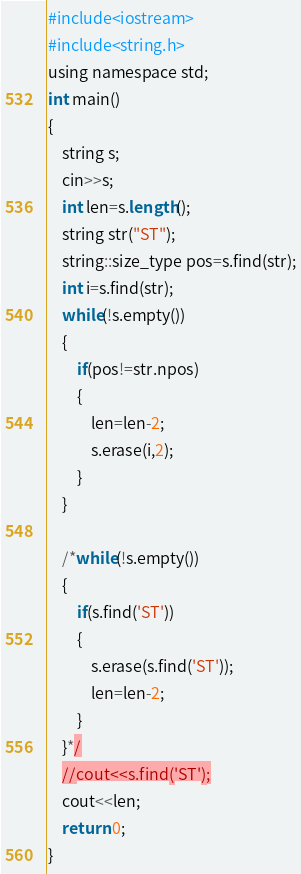<code> <loc_0><loc_0><loc_500><loc_500><_Awk_>#include<iostream>
#include<string.h>
using namespace std;
int main()
{
	string s;
	cin>>s;
	int len=s.length();
	string str("ST");
	string::size_type pos=s.find(str);
    int i=s.find(str);
    while(!s.empty())
    {
    	if(pos!=str.npos)
	    {
		    len=len-2;
		    s.erase(i,2);
	    }
	}
	
	/*while(!s.empty())
	{
		if(s.find('ST'))
		{
			s.erase(s.find('ST'));
			len=len-2;
		}
	}*/
	//cout<<s.find('ST');
	cout<<len;
	return 0;
}</code> 